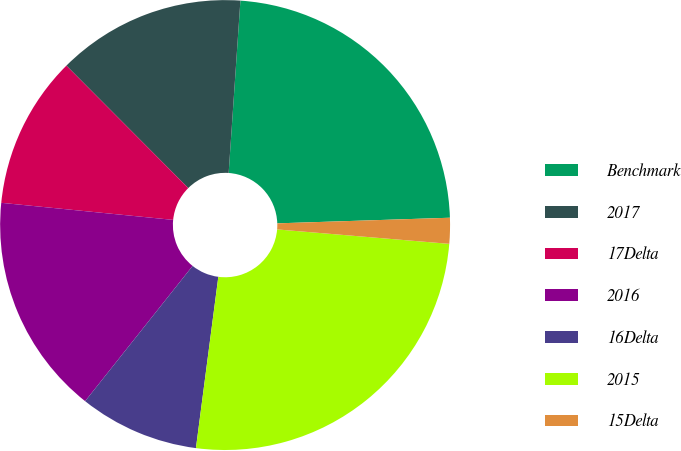Convert chart. <chart><loc_0><loc_0><loc_500><loc_500><pie_chart><fcel>Benchmark<fcel>2017<fcel>17Delta<fcel>2016<fcel>16Delta<fcel>2015<fcel>15Delta<nl><fcel>23.4%<fcel>13.55%<fcel>10.96%<fcel>15.89%<fcel>8.62%<fcel>25.74%<fcel>1.85%<nl></chart> 